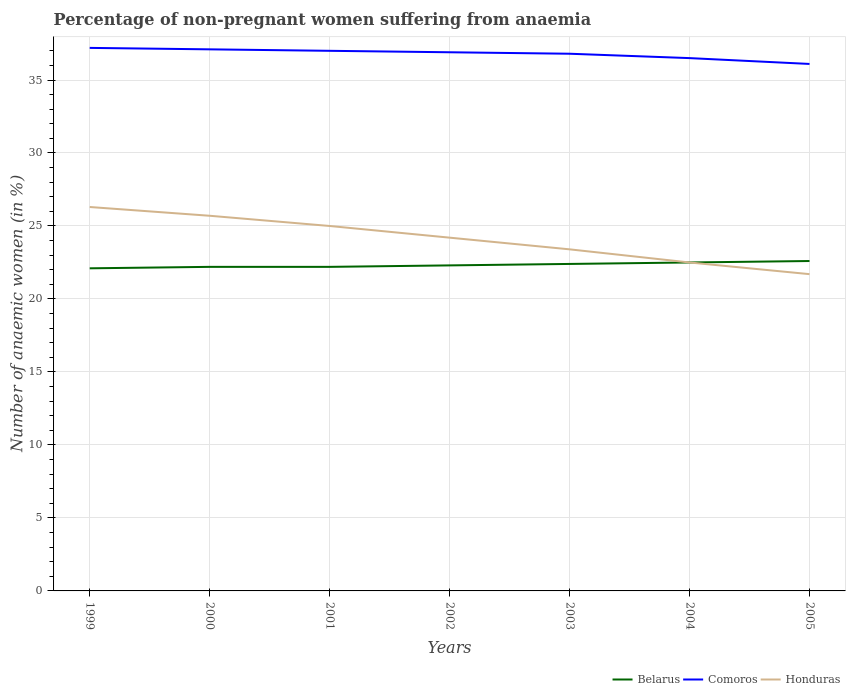How many different coloured lines are there?
Offer a very short reply. 3. Does the line corresponding to Honduras intersect with the line corresponding to Comoros?
Offer a terse response. No. Across all years, what is the maximum percentage of non-pregnant women suffering from anaemia in Belarus?
Offer a terse response. 22.1. In which year was the percentage of non-pregnant women suffering from anaemia in Belarus maximum?
Offer a very short reply. 1999. What is the total percentage of non-pregnant women suffering from anaemia in Belarus in the graph?
Your answer should be compact. -0.4. What is the difference between the highest and the second highest percentage of non-pregnant women suffering from anaemia in Comoros?
Your answer should be compact. 1.1. What is the difference between the highest and the lowest percentage of non-pregnant women suffering from anaemia in Belarus?
Your answer should be very brief. 3. What is the difference between two consecutive major ticks on the Y-axis?
Your answer should be compact. 5. Are the values on the major ticks of Y-axis written in scientific E-notation?
Make the answer very short. No. How many legend labels are there?
Keep it short and to the point. 3. How are the legend labels stacked?
Keep it short and to the point. Horizontal. What is the title of the graph?
Offer a terse response. Percentage of non-pregnant women suffering from anaemia. What is the label or title of the X-axis?
Provide a succinct answer. Years. What is the label or title of the Y-axis?
Provide a short and direct response. Number of anaemic women (in %). What is the Number of anaemic women (in %) in Belarus in 1999?
Ensure brevity in your answer.  22.1. What is the Number of anaemic women (in %) of Comoros in 1999?
Give a very brief answer. 37.2. What is the Number of anaemic women (in %) of Honduras in 1999?
Your response must be concise. 26.3. What is the Number of anaemic women (in %) in Belarus in 2000?
Provide a succinct answer. 22.2. What is the Number of anaemic women (in %) of Comoros in 2000?
Offer a terse response. 37.1. What is the Number of anaemic women (in %) in Honduras in 2000?
Offer a terse response. 25.7. What is the Number of anaemic women (in %) in Belarus in 2002?
Provide a succinct answer. 22.3. What is the Number of anaemic women (in %) of Comoros in 2002?
Offer a very short reply. 36.9. What is the Number of anaemic women (in %) in Honduras in 2002?
Give a very brief answer. 24.2. What is the Number of anaemic women (in %) in Belarus in 2003?
Keep it short and to the point. 22.4. What is the Number of anaemic women (in %) of Comoros in 2003?
Provide a short and direct response. 36.8. What is the Number of anaemic women (in %) in Honduras in 2003?
Offer a terse response. 23.4. What is the Number of anaemic women (in %) of Comoros in 2004?
Make the answer very short. 36.5. What is the Number of anaemic women (in %) of Belarus in 2005?
Offer a very short reply. 22.6. What is the Number of anaemic women (in %) in Comoros in 2005?
Keep it short and to the point. 36.1. What is the Number of anaemic women (in %) in Honduras in 2005?
Offer a very short reply. 21.7. Across all years, what is the maximum Number of anaemic women (in %) in Belarus?
Ensure brevity in your answer.  22.6. Across all years, what is the maximum Number of anaemic women (in %) in Comoros?
Make the answer very short. 37.2. Across all years, what is the maximum Number of anaemic women (in %) of Honduras?
Your answer should be very brief. 26.3. Across all years, what is the minimum Number of anaemic women (in %) of Belarus?
Make the answer very short. 22.1. Across all years, what is the minimum Number of anaemic women (in %) in Comoros?
Keep it short and to the point. 36.1. Across all years, what is the minimum Number of anaemic women (in %) in Honduras?
Ensure brevity in your answer.  21.7. What is the total Number of anaemic women (in %) in Belarus in the graph?
Your response must be concise. 156.3. What is the total Number of anaemic women (in %) in Comoros in the graph?
Your response must be concise. 257.6. What is the total Number of anaemic women (in %) in Honduras in the graph?
Your answer should be very brief. 168.8. What is the difference between the Number of anaemic women (in %) in Comoros in 1999 and that in 2000?
Your answer should be very brief. 0.1. What is the difference between the Number of anaemic women (in %) of Belarus in 1999 and that in 2001?
Keep it short and to the point. -0.1. What is the difference between the Number of anaemic women (in %) in Belarus in 1999 and that in 2002?
Keep it short and to the point. -0.2. What is the difference between the Number of anaemic women (in %) of Comoros in 1999 and that in 2002?
Provide a short and direct response. 0.3. What is the difference between the Number of anaemic women (in %) of Honduras in 1999 and that in 2002?
Provide a short and direct response. 2.1. What is the difference between the Number of anaemic women (in %) in Belarus in 1999 and that in 2004?
Keep it short and to the point. -0.4. What is the difference between the Number of anaemic women (in %) of Comoros in 2000 and that in 2002?
Your response must be concise. 0.2. What is the difference between the Number of anaemic women (in %) of Belarus in 2000 and that in 2003?
Make the answer very short. -0.2. What is the difference between the Number of anaemic women (in %) in Honduras in 2000 and that in 2004?
Your answer should be compact. 3.2. What is the difference between the Number of anaemic women (in %) of Comoros in 2000 and that in 2005?
Your answer should be very brief. 1. What is the difference between the Number of anaemic women (in %) in Honduras in 2000 and that in 2005?
Ensure brevity in your answer.  4. What is the difference between the Number of anaemic women (in %) of Belarus in 2001 and that in 2002?
Your answer should be very brief. -0.1. What is the difference between the Number of anaemic women (in %) of Comoros in 2001 and that in 2002?
Keep it short and to the point. 0.1. What is the difference between the Number of anaemic women (in %) in Honduras in 2001 and that in 2002?
Provide a succinct answer. 0.8. What is the difference between the Number of anaemic women (in %) in Belarus in 2001 and that in 2003?
Your response must be concise. -0.2. What is the difference between the Number of anaemic women (in %) of Honduras in 2001 and that in 2003?
Your answer should be compact. 1.6. What is the difference between the Number of anaemic women (in %) of Honduras in 2001 and that in 2004?
Keep it short and to the point. 2.5. What is the difference between the Number of anaemic women (in %) in Comoros in 2001 and that in 2005?
Provide a short and direct response. 0.9. What is the difference between the Number of anaemic women (in %) in Honduras in 2001 and that in 2005?
Provide a short and direct response. 3.3. What is the difference between the Number of anaemic women (in %) of Comoros in 2002 and that in 2003?
Your response must be concise. 0.1. What is the difference between the Number of anaemic women (in %) of Comoros in 2002 and that in 2005?
Offer a terse response. 0.8. What is the difference between the Number of anaemic women (in %) of Honduras in 2002 and that in 2005?
Ensure brevity in your answer.  2.5. What is the difference between the Number of anaemic women (in %) in Comoros in 2003 and that in 2004?
Ensure brevity in your answer.  0.3. What is the difference between the Number of anaemic women (in %) of Belarus in 2003 and that in 2005?
Ensure brevity in your answer.  -0.2. What is the difference between the Number of anaemic women (in %) in Honduras in 2003 and that in 2005?
Ensure brevity in your answer.  1.7. What is the difference between the Number of anaemic women (in %) of Comoros in 2004 and that in 2005?
Make the answer very short. 0.4. What is the difference between the Number of anaemic women (in %) of Belarus in 1999 and the Number of anaemic women (in %) of Comoros in 2001?
Ensure brevity in your answer.  -14.9. What is the difference between the Number of anaemic women (in %) in Belarus in 1999 and the Number of anaemic women (in %) in Honduras in 2001?
Your answer should be compact. -2.9. What is the difference between the Number of anaemic women (in %) in Comoros in 1999 and the Number of anaemic women (in %) in Honduras in 2001?
Provide a short and direct response. 12.2. What is the difference between the Number of anaemic women (in %) of Belarus in 1999 and the Number of anaemic women (in %) of Comoros in 2002?
Your answer should be compact. -14.8. What is the difference between the Number of anaemic women (in %) of Belarus in 1999 and the Number of anaemic women (in %) of Comoros in 2003?
Your answer should be very brief. -14.7. What is the difference between the Number of anaemic women (in %) in Belarus in 1999 and the Number of anaemic women (in %) in Comoros in 2004?
Make the answer very short. -14.4. What is the difference between the Number of anaemic women (in %) in Belarus in 1999 and the Number of anaemic women (in %) in Honduras in 2004?
Offer a terse response. -0.4. What is the difference between the Number of anaemic women (in %) of Comoros in 1999 and the Number of anaemic women (in %) of Honduras in 2005?
Ensure brevity in your answer.  15.5. What is the difference between the Number of anaemic women (in %) of Belarus in 2000 and the Number of anaemic women (in %) of Comoros in 2001?
Offer a terse response. -14.8. What is the difference between the Number of anaemic women (in %) of Belarus in 2000 and the Number of anaemic women (in %) of Comoros in 2002?
Keep it short and to the point. -14.7. What is the difference between the Number of anaemic women (in %) of Belarus in 2000 and the Number of anaemic women (in %) of Honduras in 2002?
Make the answer very short. -2. What is the difference between the Number of anaemic women (in %) of Belarus in 2000 and the Number of anaemic women (in %) of Comoros in 2003?
Provide a short and direct response. -14.6. What is the difference between the Number of anaemic women (in %) in Comoros in 2000 and the Number of anaemic women (in %) in Honduras in 2003?
Make the answer very short. 13.7. What is the difference between the Number of anaemic women (in %) of Belarus in 2000 and the Number of anaemic women (in %) of Comoros in 2004?
Offer a terse response. -14.3. What is the difference between the Number of anaemic women (in %) in Belarus in 2000 and the Number of anaemic women (in %) in Honduras in 2004?
Ensure brevity in your answer.  -0.3. What is the difference between the Number of anaemic women (in %) in Belarus in 2000 and the Number of anaemic women (in %) in Comoros in 2005?
Provide a succinct answer. -13.9. What is the difference between the Number of anaemic women (in %) in Belarus in 2001 and the Number of anaemic women (in %) in Comoros in 2002?
Offer a very short reply. -14.7. What is the difference between the Number of anaemic women (in %) of Belarus in 2001 and the Number of anaemic women (in %) of Comoros in 2003?
Your answer should be very brief. -14.6. What is the difference between the Number of anaemic women (in %) in Belarus in 2001 and the Number of anaemic women (in %) in Honduras in 2003?
Provide a short and direct response. -1.2. What is the difference between the Number of anaemic women (in %) in Comoros in 2001 and the Number of anaemic women (in %) in Honduras in 2003?
Your answer should be very brief. 13.6. What is the difference between the Number of anaemic women (in %) in Belarus in 2001 and the Number of anaemic women (in %) in Comoros in 2004?
Your answer should be very brief. -14.3. What is the difference between the Number of anaemic women (in %) in Belarus in 2002 and the Number of anaemic women (in %) in Honduras in 2003?
Make the answer very short. -1.1. What is the difference between the Number of anaemic women (in %) in Belarus in 2002 and the Number of anaemic women (in %) in Honduras in 2004?
Make the answer very short. -0.2. What is the difference between the Number of anaemic women (in %) in Comoros in 2002 and the Number of anaemic women (in %) in Honduras in 2004?
Provide a short and direct response. 14.4. What is the difference between the Number of anaemic women (in %) of Comoros in 2002 and the Number of anaemic women (in %) of Honduras in 2005?
Provide a short and direct response. 15.2. What is the difference between the Number of anaemic women (in %) of Belarus in 2003 and the Number of anaemic women (in %) of Comoros in 2004?
Provide a succinct answer. -14.1. What is the difference between the Number of anaemic women (in %) in Belarus in 2003 and the Number of anaemic women (in %) in Honduras in 2004?
Your answer should be very brief. -0.1. What is the difference between the Number of anaemic women (in %) of Belarus in 2003 and the Number of anaemic women (in %) of Comoros in 2005?
Your response must be concise. -13.7. What is the difference between the Number of anaemic women (in %) in Belarus in 2003 and the Number of anaemic women (in %) in Honduras in 2005?
Provide a short and direct response. 0.7. What is the difference between the Number of anaemic women (in %) of Comoros in 2003 and the Number of anaemic women (in %) of Honduras in 2005?
Provide a succinct answer. 15.1. What is the difference between the Number of anaemic women (in %) in Comoros in 2004 and the Number of anaemic women (in %) in Honduras in 2005?
Provide a succinct answer. 14.8. What is the average Number of anaemic women (in %) of Belarus per year?
Offer a terse response. 22.33. What is the average Number of anaemic women (in %) in Comoros per year?
Provide a succinct answer. 36.8. What is the average Number of anaemic women (in %) of Honduras per year?
Your response must be concise. 24.11. In the year 1999, what is the difference between the Number of anaemic women (in %) in Belarus and Number of anaemic women (in %) in Comoros?
Give a very brief answer. -15.1. In the year 2000, what is the difference between the Number of anaemic women (in %) in Belarus and Number of anaemic women (in %) in Comoros?
Provide a succinct answer. -14.9. In the year 2001, what is the difference between the Number of anaemic women (in %) in Belarus and Number of anaemic women (in %) in Comoros?
Give a very brief answer. -14.8. In the year 2001, what is the difference between the Number of anaemic women (in %) of Belarus and Number of anaemic women (in %) of Honduras?
Your response must be concise. -2.8. In the year 2002, what is the difference between the Number of anaemic women (in %) of Belarus and Number of anaemic women (in %) of Comoros?
Offer a terse response. -14.6. In the year 2002, what is the difference between the Number of anaemic women (in %) in Belarus and Number of anaemic women (in %) in Honduras?
Offer a very short reply. -1.9. In the year 2002, what is the difference between the Number of anaemic women (in %) in Comoros and Number of anaemic women (in %) in Honduras?
Make the answer very short. 12.7. In the year 2003, what is the difference between the Number of anaemic women (in %) of Belarus and Number of anaemic women (in %) of Comoros?
Your answer should be compact. -14.4. In the year 2004, what is the difference between the Number of anaemic women (in %) of Belarus and Number of anaemic women (in %) of Comoros?
Offer a very short reply. -14. In the year 2004, what is the difference between the Number of anaemic women (in %) in Comoros and Number of anaemic women (in %) in Honduras?
Offer a very short reply. 14. In the year 2005, what is the difference between the Number of anaemic women (in %) in Belarus and Number of anaemic women (in %) in Comoros?
Give a very brief answer. -13.5. In the year 2005, what is the difference between the Number of anaemic women (in %) in Belarus and Number of anaemic women (in %) in Honduras?
Offer a terse response. 0.9. What is the ratio of the Number of anaemic women (in %) in Honduras in 1999 to that in 2000?
Make the answer very short. 1.02. What is the ratio of the Number of anaemic women (in %) of Belarus in 1999 to that in 2001?
Keep it short and to the point. 1. What is the ratio of the Number of anaemic women (in %) in Comoros in 1999 to that in 2001?
Ensure brevity in your answer.  1.01. What is the ratio of the Number of anaemic women (in %) in Honduras in 1999 to that in 2001?
Provide a succinct answer. 1.05. What is the ratio of the Number of anaemic women (in %) of Belarus in 1999 to that in 2002?
Offer a very short reply. 0.99. What is the ratio of the Number of anaemic women (in %) in Comoros in 1999 to that in 2002?
Provide a short and direct response. 1.01. What is the ratio of the Number of anaemic women (in %) in Honduras in 1999 to that in 2002?
Give a very brief answer. 1.09. What is the ratio of the Number of anaemic women (in %) in Belarus in 1999 to that in 2003?
Give a very brief answer. 0.99. What is the ratio of the Number of anaemic women (in %) in Comoros in 1999 to that in 2003?
Your answer should be very brief. 1.01. What is the ratio of the Number of anaemic women (in %) in Honduras in 1999 to that in 2003?
Give a very brief answer. 1.12. What is the ratio of the Number of anaemic women (in %) of Belarus in 1999 to that in 2004?
Your answer should be compact. 0.98. What is the ratio of the Number of anaemic women (in %) of Comoros in 1999 to that in 2004?
Your answer should be very brief. 1.02. What is the ratio of the Number of anaemic women (in %) in Honduras in 1999 to that in 2004?
Your response must be concise. 1.17. What is the ratio of the Number of anaemic women (in %) in Belarus in 1999 to that in 2005?
Offer a very short reply. 0.98. What is the ratio of the Number of anaemic women (in %) of Comoros in 1999 to that in 2005?
Offer a very short reply. 1.03. What is the ratio of the Number of anaemic women (in %) of Honduras in 1999 to that in 2005?
Keep it short and to the point. 1.21. What is the ratio of the Number of anaemic women (in %) of Comoros in 2000 to that in 2001?
Offer a terse response. 1. What is the ratio of the Number of anaemic women (in %) of Honduras in 2000 to that in 2001?
Keep it short and to the point. 1.03. What is the ratio of the Number of anaemic women (in %) of Comoros in 2000 to that in 2002?
Your answer should be very brief. 1.01. What is the ratio of the Number of anaemic women (in %) in Honduras in 2000 to that in 2002?
Your answer should be very brief. 1.06. What is the ratio of the Number of anaemic women (in %) of Comoros in 2000 to that in 2003?
Your answer should be compact. 1.01. What is the ratio of the Number of anaemic women (in %) in Honduras in 2000 to that in 2003?
Your response must be concise. 1.1. What is the ratio of the Number of anaemic women (in %) in Belarus in 2000 to that in 2004?
Your response must be concise. 0.99. What is the ratio of the Number of anaemic women (in %) in Comoros in 2000 to that in 2004?
Make the answer very short. 1.02. What is the ratio of the Number of anaemic women (in %) of Honduras in 2000 to that in 2004?
Your response must be concise. 1.14. What is the ratio of the Number of anaemic women (in %) of Belarus in 2000 to that in 2005?
Make the answer very short. 0.98. What is the ratio of the Number of anaemic women (in %) in Comoros in 2000 to that in 2005?
Your answer should be compact. 1.03. What is the ratio of the Number of anaemic women (in %) of Honduras in 2000 to that in 2005?
Make the answer very short. 1.18. What is the ratio of the Number of anaemic women (in %) in Belarus in 2001 to that in 2002?
Offer a terse response. 1. What is the ratio of the Number of anaemic women (in %) in Comoros in 2001 to that in 2002?
Offer a very short reply. 1. What is the ratio of the Number of anaemic women (in %) of Honduras in 2001 to that in 2002?
Provide a short and direct response. 1.03. What is the ratio of the Number of anaemic women (in %) of Comoros in 2001 to that in 2003?
Provide a short and direct response. 1.01. What is the ratio of the Number of anaemic women (in %) in Honduras in 2001 to that in 2003?
Ensure brevity in your answer.  1.07. What is the ratio of the Number of anaemic women (in %) in Belarus in 2001 to that in 2004?
Provide a short and direct response. 0.99. What is the ratio of the Number of anaemic women (in %) in Comoros in 2001 to that in 2004?
Provide a short and direct response. 1.01. What is the ratio of the Number of anaemic women (in %) of Belarus in 2001 to that in 2005?
Keep it short and to the point. 0.98. What is the ratio of the Number of anaemic women (in %) in Comoros in 2001 to that in 2005?
Offer a terse response. 1.02. What is the ratio of the Number of anaemic women (in %) of Honduras in 2001 to that in 2005?
Give a very brief answer. 1.15. What is the ratio of the Number of anaemic women (in %) in Belarus in 2002 to that in 2003?
Give a very brief answer. 1. What is the ratio of the Number of anaemic women (in %) in Comoros in 2002 to that in 2003?
Your answer should be very brief. 1. What is the ratio of the Number of anaemic women (in %) in Honduras in 2002 to that in 2003?
Give a very brief answer. 1.03. What is the ratio of the Number of anaemic women (in %) of Belarus in 2002 to that in 2004?
Your response must be concise. 0.99. What is the ratio of the Number of anaemic women (in %) of Comoros in 2002 to that in 2004?
Provide a short and direct response. 1.01. What is the ratio of the Number of anaemic women (in %) of Honduras in 2002 to that in 2004?
Your response must be concise. 1.08. What is the ratio of the Number of anaemic women (in %) in Belarus in 2002 to that in 2005?
Offer a terse response. 0.99. What is the ratio of the Number of anaemic women (in %) of Comoros in 2002 to that in 2005?
Your answer should be compact. 1.02. What is the ratio of the Number of anaemic women (in %) in Honduras in 2002 to that in 2005?
Offer a very short reply. 1.12. What is the ratio of the Number of anaemic women (in %) of Comoros in 2003 to that in 2004?
Keep it short and to the point. 1.01. What is the ratio of the Number of anaemic women (in %) in Comoros in 2003 to that in 2005?
Ensure brevity in your answer.  1.02. What is the ratio of the Number of anaemic women (in %) of Honduras in 2003 to that in 2005?
Offer a very short reply. 1.08. What is the ratio of the Number of anaemic women (in %) in Belarus in 2004 to that in 2005?
Your answer should be very brief. 1. What is the ratio of the Number of anaemic women (in %) of Comoros in 2004 to that in 2005?
Your response must be concise. 1.01. What is the ratio of the Number of anaemic women (in %) in Honduras in 2004 to that in 2005?
Your response must be concise. 1.04. What is the difference between the highest and the second highest Number of anaemic women (in %) in Comoros?
Your response must be concise. 0.1. What is the difference between the highest and the second highest Number of anaemic women (in %) in Honduras?
Provide a succinct answer. 0.6. What is the difference between the highest and the lowest Number of anaemic women (in %) in Comoros?
Offer a terse response. 1.1. What is the difference between the highest and the lowest Number of anaemic women (in %) in Honduras?
Make the answer very short. 4.6. 